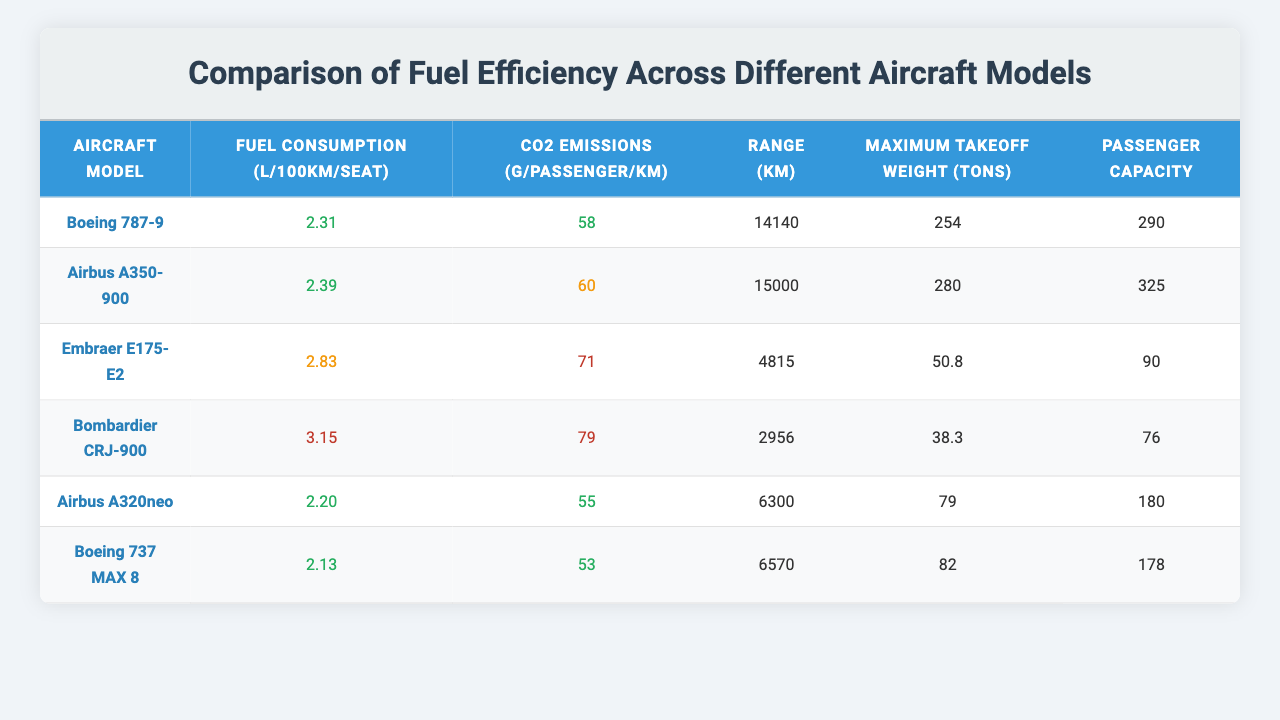What is the fuel consumption of the Boeing 787-9? According to the table, the fuel consumption of the Boeing 787-9 is listed as 2.31 L/100km/seat.
Answer: 2.31 L/100km/seat Which aircraft has the lowest CO2 emissions per passenger? By examining the CO2 emissions column, the Airbus A320neo shows the lowest emissions at 55 g/passenger/km.
Answer: Airbus A320neo What is the maximum range of the Airbus A350-900? Looking at the range column for the Airbus A350-900, it has a maximum range of 15,000 km.
Answer: 15,000 km How many aircraft models have a passenger capacity greater than 200? The aircraft with passenger capacities greater than 200 are the Airbus A350-900 (325), Boeing 787-9 (290), and Airbus A320neo (180), totaling 3 models.
Answer: 3 models What is the average fuel consumption for all listed aircraft? The fuel consumptions are: 2.31, 2.39, 2.83, 3.15, 2.20, and 2.13. Summing these gives 2.31 + 2.39 + 2.83 + 3.15 + 2.20 + 2.13 = 15.01. Dividing by 6 gives an average of 15.01 / 6 = 2.50.
Answer: 2.50 L/100km/seat Is the CO2 emissions of the Bombardier CRJ-900 considered efficient? The CO2 emissions for the Bombardier CRJ-900 is 79 g/passenger/km, which is above the 70 g/passenger/km threshold for efficiency, making it inefficient.
Answer: No Which aircraft has the highest passenger capacity and what is that capacity? The Airbus A350-900 shows the highest passenger capacity at 325.
Answer: Airbus A350-900, 325 passengers If we compare the fuel consumption of the Boeing 737 MAX 8 and the Embraer E175-E2, which one is more fuel-efficient? The fuel consumption of the Boeing 737 MAX 8 is 2.13 L/100km/seat and the Embraer E175-E2 is 2.83 L/100km/seat. Since 2.13 < 2.83, the Boeing 737 MAX 8 is more fuel-efficient.
Answer: Boeing 737 MAX 8 What is the difference in maximum takeoff weight between the Airbus A350-900 and the Bombardier CRJ-900? The maximum takeoff weight for the Airbus A350-900 is 280 tons and for the Bombardier CRJ-900 is 38.3 tons. The difference is 280 - 38.3 = 241.7 tons.
Answer: 241.7 tons Is the fuel consumption of the Airbus A320neo classed as good? The Airbus A320neo has a fuel consumption of 2.20 L/100km/seat, which is below 2.5, classifying it as good.
Answer: Yes 